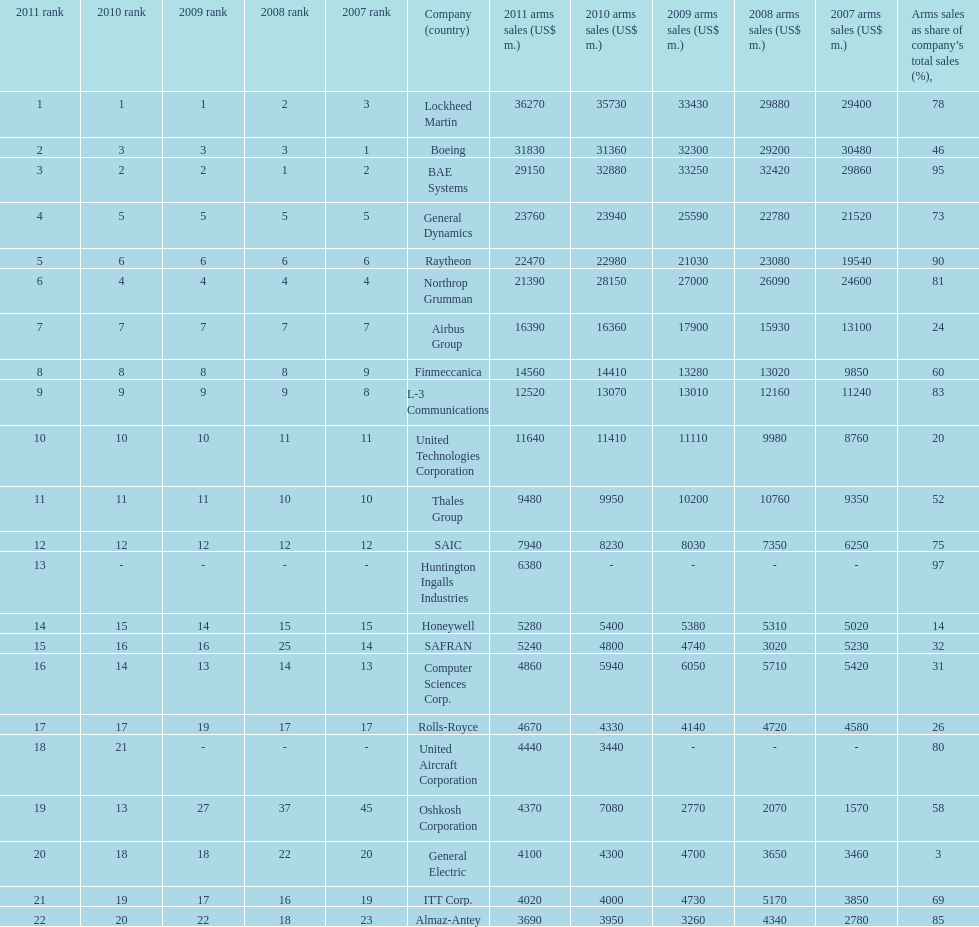In 2010, who has the least amount of sales? United Aircraft Corporation. 